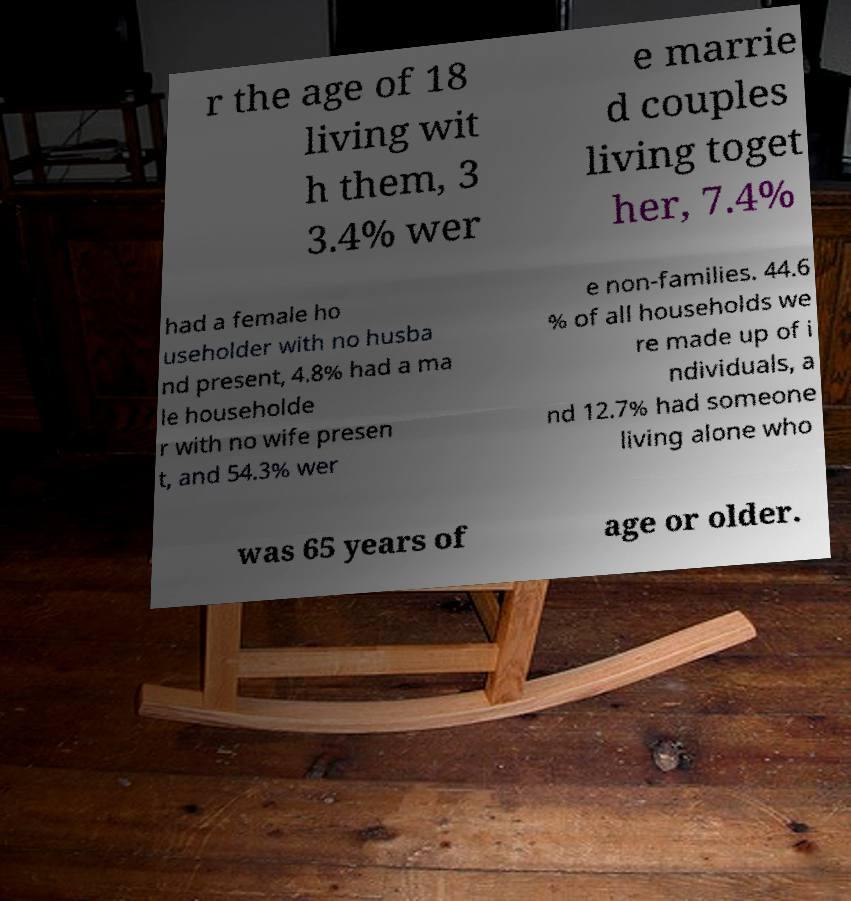Please identify and transcribe the text found in this image. r the age of 18 living wit h them, 3 3.4% wer e marrie d couples living toget her, 7.4% had a female ho useholder with no husba nd present, 4.8% had a ma le householde r with no wife presen t, and 54.3% wer e non-families. 44.6 % of all households we re made up of i ndividuals, a nd 12.7% had someone living alone who was 65 years of age or older. 